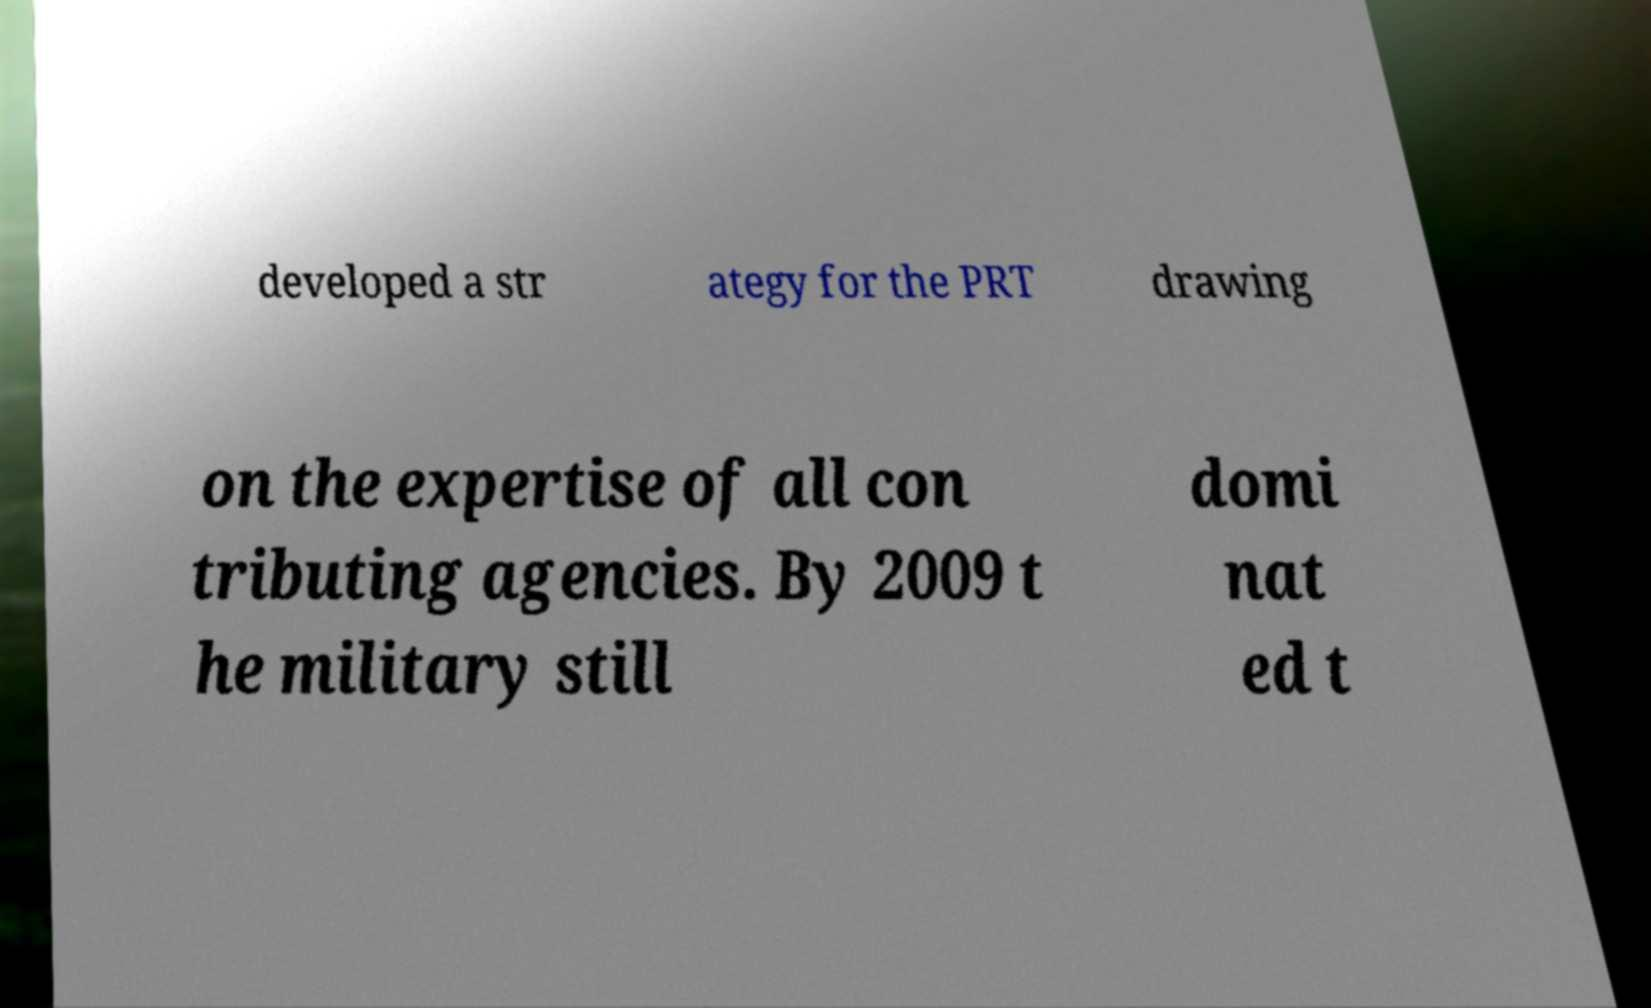What messages or text are displayed in this image? I need them in a readable, typed format. developed a str ategy for the PRT drawing on the expertise of all con tributing agencies. By 2009 t he military still domi nat ed t 